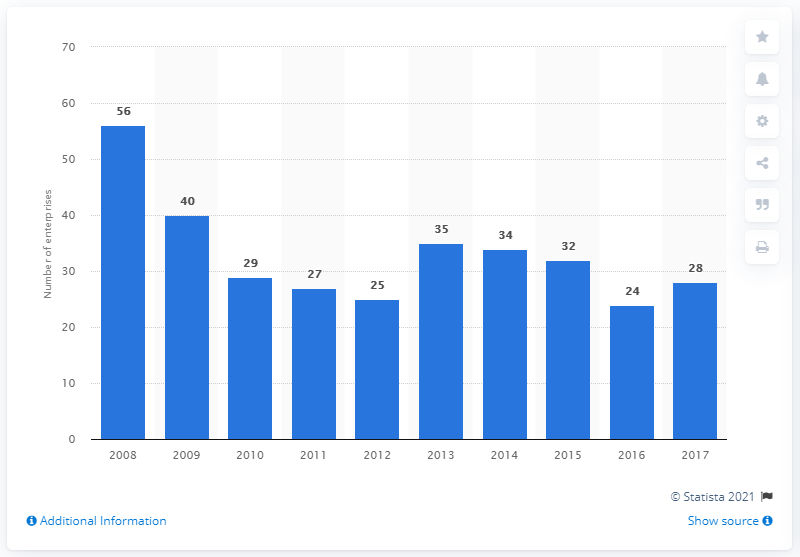Outline some significant characteristics in this image. In 2017, there were 28 enterprises in the manufacture of electric domestic appliances industry in Belgium. 